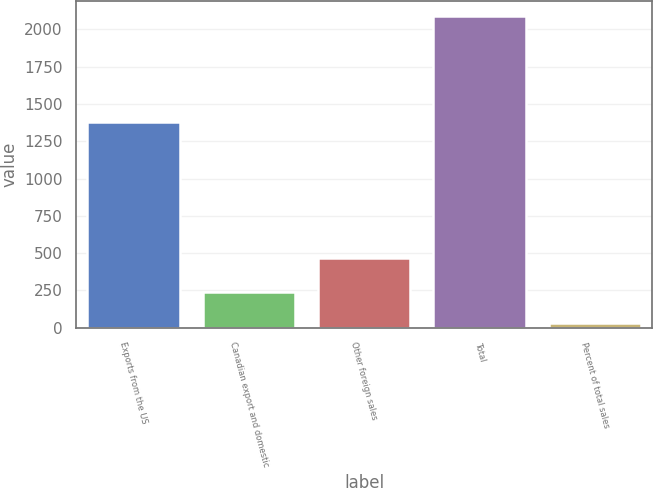Convert chart to OTSL. <chart><loc_0><loc_0><loc_500><loc_500><bar_chart><fcel>Exports from the US<fcel>Canadian export and domestic<fcel>Other foreign sales<fcel>Total<fcel>Percent of total sales<nl><fcel>1381<fcel>240<fcel>467<fcel>2088<fcel>32<nl></chart> 